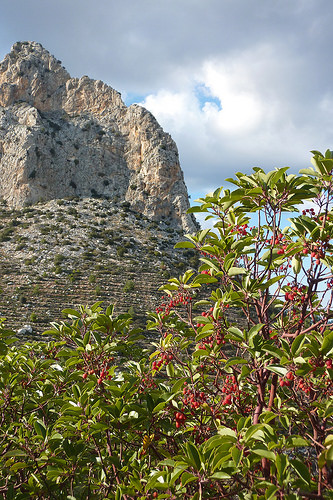<image>
Can you confirm if the rock is in front of the tree? No. The rock is not in front of the tree. The spatial positioning shows a different relationship between these objects. 